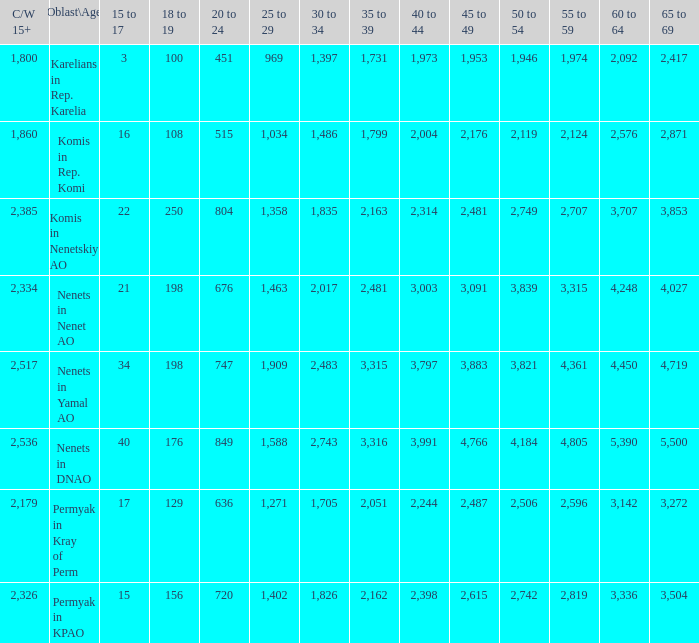With a 20 to 24 beneath 676, and a 15 to 17 beyond 16, and a 60 to 64 None. 